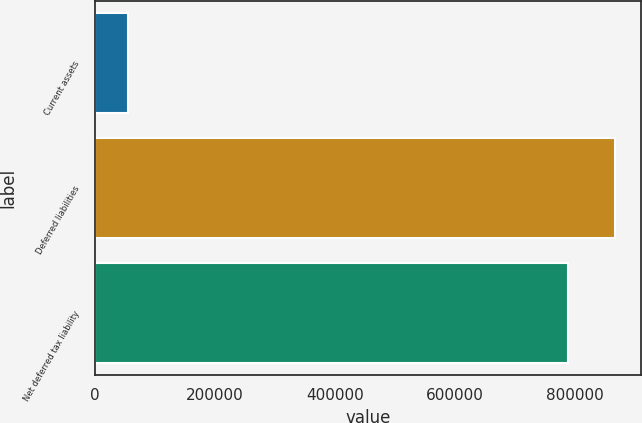<chart> <loc_0><loc_0><loc_500><loc_500><bar_chart><fcel>Current assets<fcel>Deferred liabilities<fcel>Net deferred tax liability<nl><fcel>54704<fcel>867784<fcel>788895<nl></chart> 